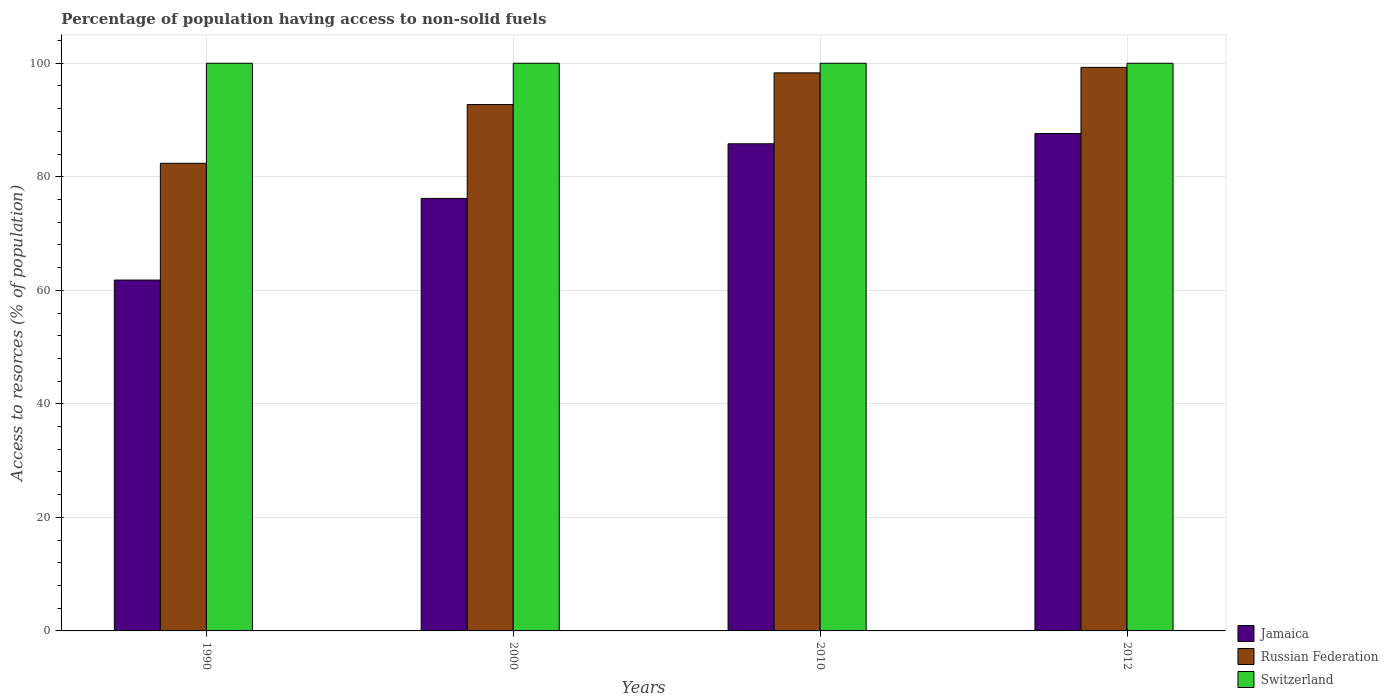Are the number of bars per tick equal to the number of legend labels?
Ensure brevity in your answer.  Yes. Are the number of bars on each tick of the X-axis equal?
Your answer should be very brief. Yes. How many bars are there on the 4th tick from the right?
Keep it short and to the point. 3. In how many cases, is the number of bars for a given year not equal to the number of legend labels?
Ensure brevity in your answer.  0. What is the percentage of population having access to non-solid fuels in Jamaica in 2012?
Ensure brevity in your answer.  87.63. Across all years, what is the maximum percentage of population having access to non-solid fuels in Russian Federation?
Ensure brevity in your answer.  99.27. Across all years, what is the minimum percentage of population having access to non-solid fuels in Russian Federation?
Offer a very short reply. 82.38. What is the total percentage of population having access to non-solid fuels in Switzerland in the graph?
Offer a terse response. 400. What is the difference between the percentage of population having access to non-solid fuels in Jamaica in 1990 and that in 2010?
Your answer should be compact. -24.01. What is the difference between the percentage of population having access to non-solid fuels in Jamaica in 2010 and the percentage of population having access to non-solid fuels in Switzerland in 1990?
Provide a succinct answer. -14.18. What is the average percentage of population having access to non-solid fuels in Jamaica per year?
Provide a succinct answer. 77.86. In the year 2000, what is the difference between the percentage of population having access to non-solid fuels in Switzerland and percentage of population having access to non-solid fuels in Jamaica?
Keep it short and to the point. 23.81. In how many years, is the percentage of population having access to non-solid fuels in Russian Federation greater than 12 %?
Offer a terse response. 4. What is the ratio of the percentage of population having access to non-solid fuels in Switzerland in 1990 to that in 2010?
Make the answer very short. 1. Is the percentage of population having access to non-solid fuels in Russian Federation in 1990 less than that in 2010?
Offer a very short reply. Yes. What is the difference between the highest and the lowest percentage of population having access to non-solid fuels in Jamaica?
Your response must be concise. 25.82. Is the sum of the percentage of population having access to non-solid fuels in Russian Federation in 1990 and 2012 greater than the maximum percentage of population having access to non-solid fuels in Jamaica across all years?
Your answer should be compact. Yes. What does the 2nd bar from the left in 1990 represents?
Make the answer very short. Russian Federation. What does the 3rd bar from the right in 2000 represents?
Keep it short and to the point. Jamaica. Is it the case that in every year, the sum of the percentage of population having access to non-solid fuels in Russian Federation and percentage of population having access to non-solid fuels in Switzerland is greater than the percentage of population having access to non-solid fuels in Jamaica?
Your answer should be very brief. Yes. Are the values on the major ticks of Y-axis written in scientific E-notation?
Provide a short and direct response. No. Does the graph contain grids?
Keep it short and to the point. Yes. Where does the legend appear in the graph?
Provide a succinct answer. Bottom right. How many legend labels are there?
Provide a short and direct response. 3. How are the legend labels stacked?
Offer a terse response. Vertical. What is the title of the graph?
Provide a succinct answer. Percentage of population having access to non-solid fuels. What is the label or title of the X-axis?
Ensure brevity in your answer.  Years. What is the label or title of the Y-axis?
Offer a terse response. Access to resorces (% of population). What is the Access to resorces (% of population) of Jamaica in 1990?
Your answer should be compact. 61.81. What is the Access to resorces (% of population) in Russian Federation in 1990?
Offer a very short reply. 82.38. What is the Access to resorces (% of population) in Switzerland in 1990?
Offer a very short reply. 100. What is the Access to resorces (% of population) of Jamaica in 2000?
Ensure brevity in your answer.  76.19. What is the Access to resorces (% of population) of Russian Federation in 2000?
Keep it short and to the point. 92.72. What is the Access to resorces (% of population) of Switzerland in 2000?
Ensure brevity in your answer.  100. What is the Access to resorces (% of population) in Jamaica in 2010?
Provide a succinct answer. 85.82. What is the Access to resorces (% of population) in Russian Federation in 2010?
Your answer should be compact. 98.31. What is the Access to resorces (% of population) of Switzerland in 2010?
Your response must be concise. 100. What is the Access to resorces (% of population) of Jamaica in 2012?
Your response must be concise. 87.63. What is the Access to resorces (% of population) of Russian Federation in 2012?
Provide a succinct answer. 99.27. What is the Access to resorces (% of population) of Switzerland in 2012?
Your answer should be compact. 100. Across all years, what is the maximum Access to resorces (% of population) in Jamaica?
Your response must be concise. 87.63. Across all years, what is the maximum Access to resorces (% of population) in Russian Federation?
Provide a succinct answer. 99.27. Across all years, what is the maximum Access to resorces (% of population) of Switzerland?
Offer a very short reply. 100. Across all years, what is the minimum Access to resorces (% of population) of Jamaica?
Provide a short and direct response. 61.81. Across all years, what is the minimum Access to resorces (% of population) of Russian Federation?
Give a very brief answer. 82.38. Across all years, what is the minimum Access to resorces (% of population) in Switzerland?
Ensure brevity in your answer.  100. What is the total Access to resorces (% of population) in Jamaica in the graph?
Offer a very short reply. 311.44. What is the total Access to resorces (% of population) of Russian Federation in the graph?
Your response must be concise. 372.68. What is the difference between the Access to resorces (% of population) in Jamaica in 1990 and that in 2000?
Ensure brevity in your answer.  -14.38. What is the difference between the Access to resorces (% of population) in Russian Federation in 1990 and that in 2000?
Keep it short and to the point. -10.34. What is the difference between the Access to resorces (% of population) in Switzerland in 1990 and that in 2000?
Make the answer very short. 0. What is the difference between the Access to resorces (% of population) of Jamaica in 1990 and that in 2010?
Your answer should be compact. -24.01. What is the difference between the Access to resorces (% of population) of Russian Federation in 1990 and that in 2010?
Your answer should be compact. -15.93. What is the difference between the Access to resorces (% of population) of Jamaica in 1990 and that in 2012?
Your response must be concise. -25.82. What is the difference between the Access to resorces (% of population) in Russian Federation in 1990 and that in 2012?
Provide a succinct answer. -16.89. What is the difference between the Access to resorces (% of population) of Switzerland in 1990 and that in 2012?
Provide a short and direct response. 0. What is the difference between the Access to resorces (% of population) in Jamaica in 2000 and that in 2010?
Keep it short and to the point. -9.62. What is the difference between the Access to resorces (% of population) of Russian Federation in 2000 and that in 2010?
Offer a very short reply. -5.59. What is the difference between the Access to resorces (% of population) in Switzerland in 2000 and that in 2010?
Your answer should be compact. 0. What is the difference between the Access to resorces (% of population) of Jamaica in 2000 and that in 2012?
Provide a short and direct response. -11.44. What is the difference between the Access to resorces (% of population) in Russian Federation in 2000 and that in 2012?
Ensure brevity in your answer.  -6.55. What is the difference between the Access to resorces (% of population) of Switzerland in 2000 and that in 2012?
Provide a short and direct response. 0. What is the difference between the Access to resorces (% of population) in Jamaica in 2010 and that in 2012?
Your response must be concise. -1.81. What is the difference between the Access to resorces (% of population) of Russian Federation in 2010 and that in 2012?
Keep it short and to the point. -0.96. What is the difference between the Access to resorces (% of population) in Jamaica in 1990 and the Access to resorces (% of population) in Russian Federation in 2000?
Offer a very short reply. -30.91. What is the difference between the Access to resorces (% of population) in Jamaica in 1990 and the Access to resorces (% of population) in Switzerland in 2000?
Keep it short and to the point. -38.19. What is the difference between the Access to resorces (% of population) of Russian Federation in 1990 and the Access to resorces (% of population) of Switzerland in 2000?
Make the answer very short. -17.62. What is the difference between the Access to resorces (% of population) in Jamaica in 1990 and the Access to resorces (% of population) in Russian Federation in 2010?
Ensure brevity in your answer.  -36.5. What is the difference between the Access to resorces (% of population) in Jamaica in 1990 and the Access to resorces (% of population) in Switzerland in 2010?
Ensure brevity in your answer.  -38.19. What is the difference between the Access to resorces (% of population) in Russian Federation in 1990 and the Access to resorces (% of population) in Switzerland in 2010?
Your answer should be compact. -17.62. What is the difference between the Access to resorces (% of population) in Jamaica in 1990 and the Access to resorces (% of population) in Russian Federation in 2012?
Provide a short and direct response. -37.46. What is the difference between the Access to resorces (% of population) of Jamaica in 1990 and the Access to resorces (% of population) of Switzerland in 2012?
Offer a very short reply. -38.19. What is the difference between the Access to resorces (% of population) of Russian Federation in 1990 and the Access to resorces (% of population) of Switzerland in 2012?
Keep it short and to the point. -17.62. What is the difference between the Access to resorces (% of population) of Jamaica in 2000 and the Access to resorces (% of population) of Russian Federation in 2010?
Provide a short and direct response. -22.12. What is the difference between the Access to resorces (% of population) in Jamaica in 2000 and the Access to resorces (% of population) in Switzerland in 2010?
Offer a very short reply. -23.81. What is the difference between the Access to resorces (% of population) in Russian Federation in 2000 and the Access to resorces (% of population) in Switzerland in 2010?
Your answer should be very brief. -7.28. What is the difference between the Access to resorces (% of population) of Jamaica in 2000 and the Access to resorces (% of population) of Russian Federation in 2012?
Your answer should be very brief. -23.08. What is the difference between the Access to resorces (% of population) in Jamaica in 2000 and the Access to resorces (% of population) in Switzerland in 2012?
Offer a very short reply. -23.81. What is the difference between the Access to resorces (% of population) of Russian Federation in 2000 and the Access to resorces (% of population) of Switzerland in 2012?
Offer a very short reply. -7.28. What is the difference between the Access to resorces (% of population) of Jamaica in 2010 and the Access to resorces (% of population) of Russian Federation in 2012?
Provide a short and direct response. -13.46. What is the difference between the Access to resorces (% of population) in Jamaica in 2010 and the Access to resorces (% of population) in Switzerland in 2012?
Offer a very short reply. -14.18. What is the difference between the Access to resorces (% of population) of Russian Federation in 2010 and the Access to resorces (% of population) of Switzerland in 2012?
Your answer should be compact. -1.69. What is the average Access to resorces (% of population) in Jamaica per year?
Make the answer very short. 77.86. What is the average Access to resorces (% of population) of Russian Federation per year?
Your response must be concise. 93.17. What is the average Access to resorces (% of population) in Switzerland per year?
Make the answer very short. 100. In the year 1990, what is the difference between the Access to resorces (% of population) in Jamaica and Access to resorces (% of population) in Russian Federation?
Ensure brevity in your answer.  -20.57. In the year 1990, what is the difference between the Access to resorces (% of population) in Jamaica and Access to resorces (% of population) in Switzerland?
Ensure brevity in your answer.  -38.19. In the year 1990, what is the difference between the Access to resorces (% of population) in Russian Federation and Access to resorces (% of population) in Switzerland?
Keep it short and to the point. -17.62. In the year 2000, what is the difference between the Access to resorces (% of population) of Jamaica and Access to resorces (% of population) of Russian Federation?
Make the answer very short. -16.53. In the year 2000, what is the difference between the Access to resorces (% of population) of Jamaica and Access to resorces (% of population) of Switzerland?
Your answer should be very brief. -23.81. In the year 2000, what is the difference between the Access to resorces (% of population) of Russian Federation and Access to resorces (% of population) of Switzerland?
Keep it short and to the point. -7.28. In the year 2010, what is the difference between the Access to resorces (% of population) of Jamaica and Access to resorces (% of population) of Russian Federation?
Keep it short and to the point. -12.49. In the year 2010, what is the difference between the Access to resorces (% of population) of Jamaica and Access to resorces (% of population) of Switzerland?
Your response must be concise. -14.18. In the year 2010, what is the difference between the Access to resorces (% of population) in Russian Federation and Access to resorces (% of population) in Switzerland?
Provide a succinct answer. -1.69. In the year 2012, what is the difference between the Access to resorces (% of population) in Jamaica and Access to resorces (% of population) in Russian Federation?
Keep it short and to the point. -11.64. In the year 2012, what is the difference between the Access to resorces (% of population) in Jamaica and Access to resorces (% of population) in Switzerland?
Give a very brief answer. -12.37. In the year 2012, what is the difference between the Access to resorces (% of population) in Russian Federation and Access to resorces (% of population) in Switzerland?
Your response must be concise. -0.73. What is the ratio of the Access to resorces (% of population) in Jamaica in 1990 to that in 2000?
Keep it short and to the point. 0.81. What is the ratio of the Access to resorces (% of population) in Russian Federation in 1990 to that in 2000?
Your answer should be compact. 0.89. What is the ratio of the Access to resorces (% of population) in Jamaica in 1990 to that in 2010?
Keep it short and to the point. 0.72. What is the ratio of the Access to resorces (% of population) in Russian Federation in 1990 to that in 2010?
Provide a short and direct response. 0.84. What is the ratio of the Access to resorces (% of population) in Switzerland in 1990 to that in 2010?
Ensure brevity in your answer.  1. What is the ratio of the Access to resorces (% of population) of Jamaica in 1990 to that in 2012?
Offer a terse response. 0.71. What is the ratio of the Access to resorces (% of population) in Russian Federation in 1990 to that in 2012?
Your answer should be very brief. 0.83. What is the ratio of the Access to resorces (% of population) of Switzerland in 1990 to that in 2012?
Make the answer very short. 1. What is the ratio of the Access to resorces (% of population) in Jamaica in 2000 to that in 2010?
Your answer should be very brief. 0.89. What is the ratio of the Access to resorces (% of population) in Russian Federation in 2000 to that in 2010?
Provide a succinct answer. 0.94. What is the ratio of the Access to resorces (% of population) in Switzerland in 2000 to that in 2010?
Offer a terse response. 1. What is the ratio of the Access to resorces (% of population) in Jamaica in 2000 to that in 2012?
Provide a short and direct response. 0.87. What is the ratio of the Access to resorces (% of population) of Russian Federation in 2000 to that in 2012?
Provide a succinct answer. 0.93. What is the ratio of the Access to resorces (% of population) in Jamaica in 2010 to that in 2012?
Your response must be concise. 0.98. What is the ratio of the Access to resorces (% of population) of Russian Federation in 2010 to that in 2012?
Your response must be concise. 0.99. What is the difference between the highest and the second highest Access to resorces (% of population) in Jamaica?
Offer a very short reply. 1.81. What is the difference between the highest and the second highest Access to resorces (% of population) of Russian Federation?
Ensure brevity in your answer.  0.96. What is the difference between the highest and the lowest Access to resorces (% of population) of Jamaica?
Offer a terse response. 25.82. What is the difference between the highest and the lowest Access to resorces (% of population) of Russian Federation?
Provide a succinct answer. 16.89. What is the difference between the highest and the lowest Access to resorces (% of population) in Switzerland?
Provide a short and direct response. 0. 